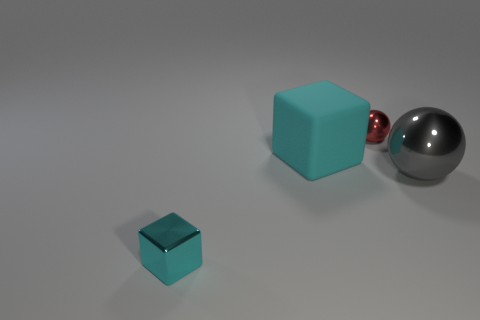Add 2 big yellow metallic cylinders. How many objects exist? 6 Add 2 brown metal balls. How many brown metal balls exist? 2 Subtract 1 gray balls. How many objects are left? 3 Subtract all cyan shiny objects. Subtract all big things. How many objects are left? 1 Add 2 big gray metal spheres. How many big gray metal spheres are left? 3 